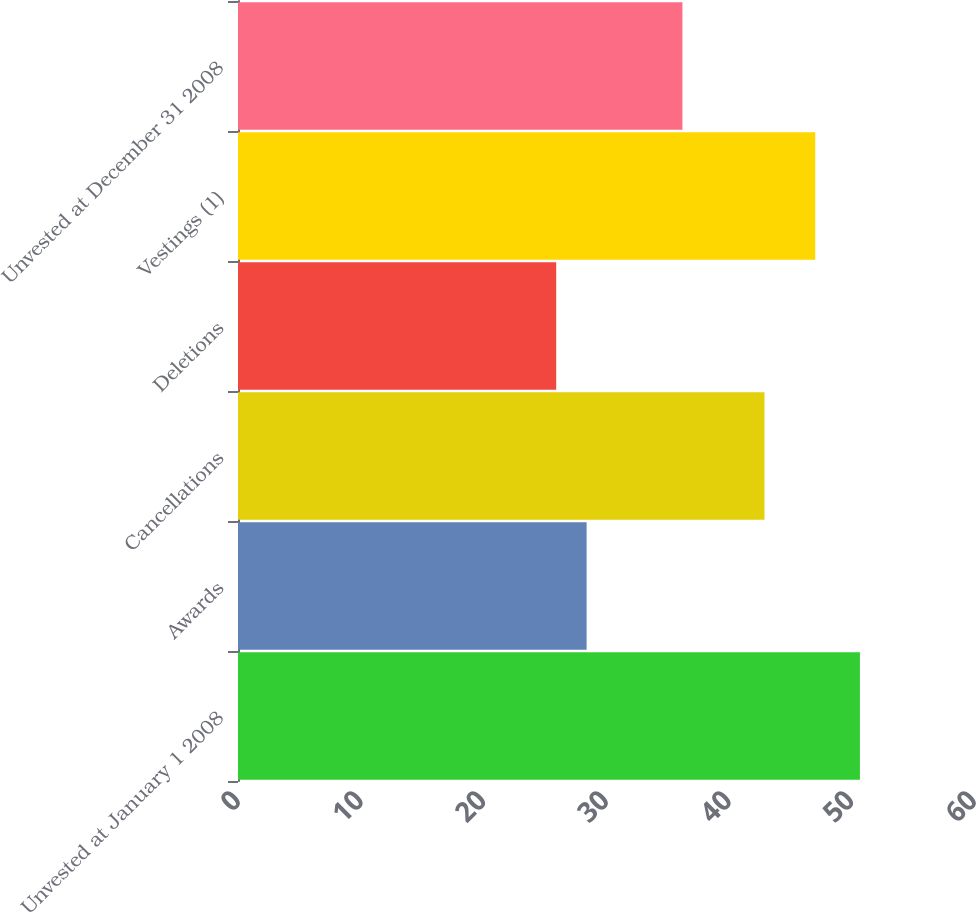Convert chart. <chart><loc_0><loc_0><loc_500><loc_500><bar_chart><fcel>Unvested at January 1 2008<fcel>Awards<fcel>Cancellations<fcel>Deletions<fcel>Vestings (1)<fcel>Unvested at December 31 2008<nl><fcel>50.7<fcel>28.42<fcel>42.92<fcel>25.94<fcel>47.06<fcel>36.23<nl></chart> 